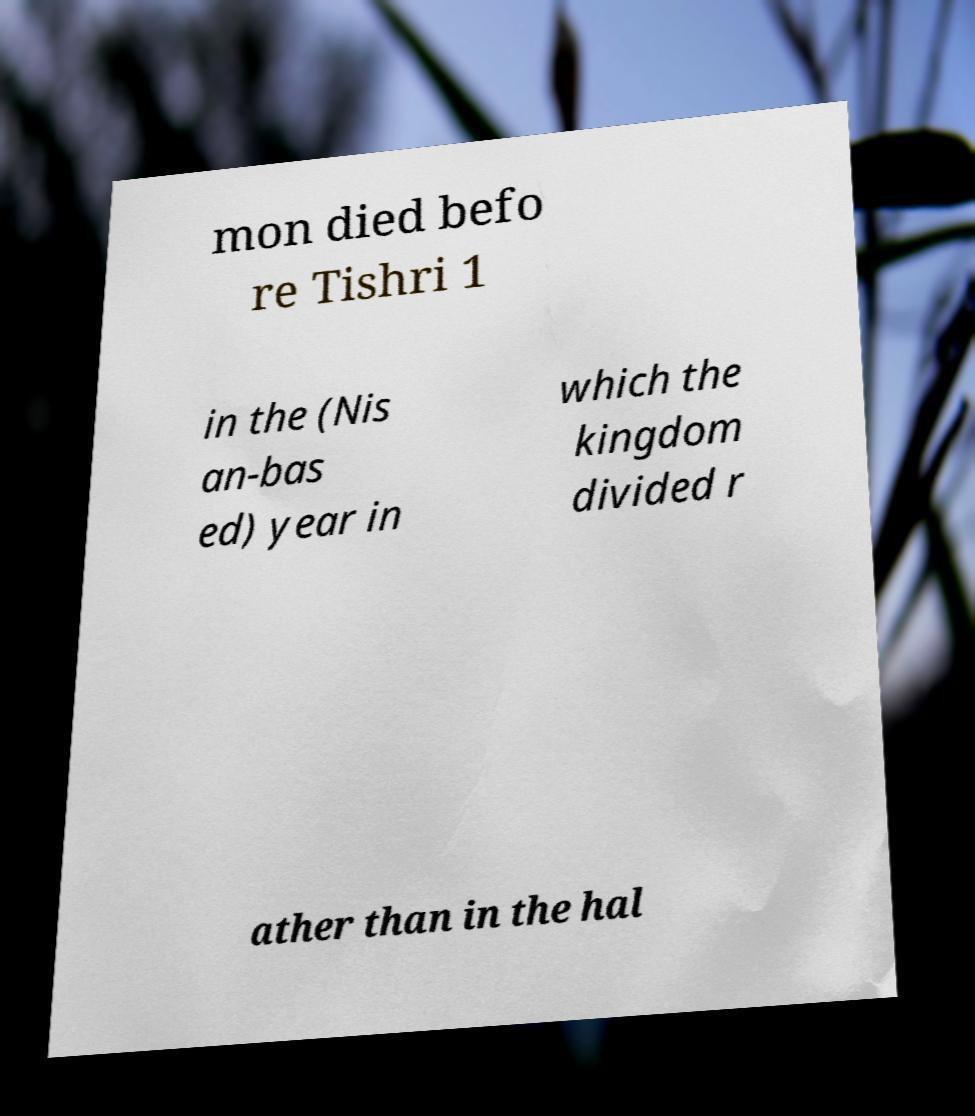Can you accurately transcribe the text from the provided image for me? mon died befo re Tishri 1 in the (Nis an-bas ed) year in which the kingdom divided r ather than in the hal 